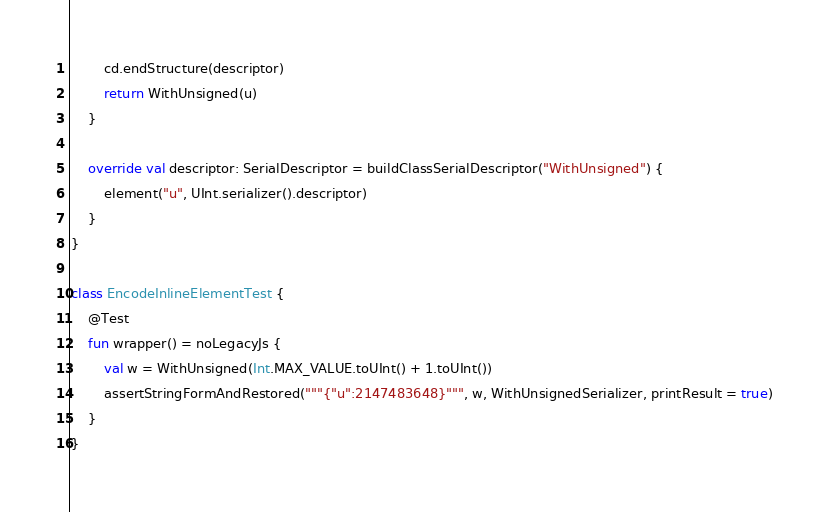Convert code to text. <code><loc_0><loc_0><loc_500><loc_500><_Kotlin_>        cd.endStructure(descriptor)
        return WithUnsigned(u)
    }

    override val descriptor: SerialDescriptor = buildClassSerialDescriptor("WithUnsigned") {
        element("u", UInt.serializer().descriptor)
    }
}

class EncodeInlineElementTest {
    @Test
    fun wrapper() = noLegacyJs {
        val w = WithUnsigned(Int.MAX_VALUE.toUInt() + 1.toUInt())
        assertStringFormAndRestored("""{"u":2147483648}""", w, WithUnsignedSerializer, printResult = true)
    }
}
</code> 